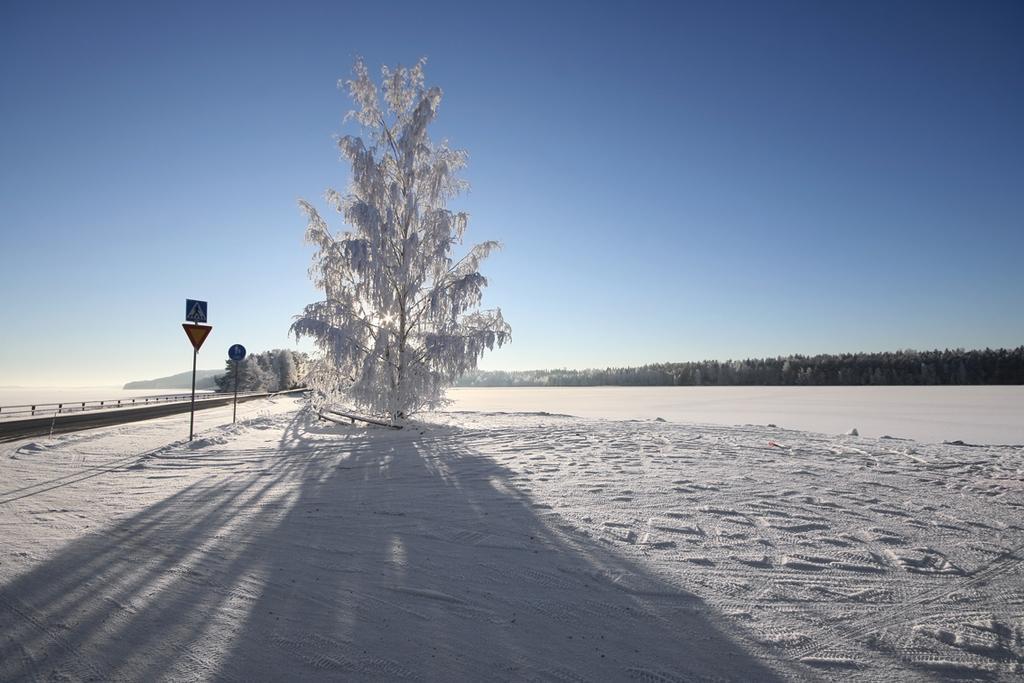Describe this image in one or two sentences. In the image there is a land covered with dense snow and there is a tree, it is also completely covered with snow and in the background there are some trees and on the left side there are two caution boards. 